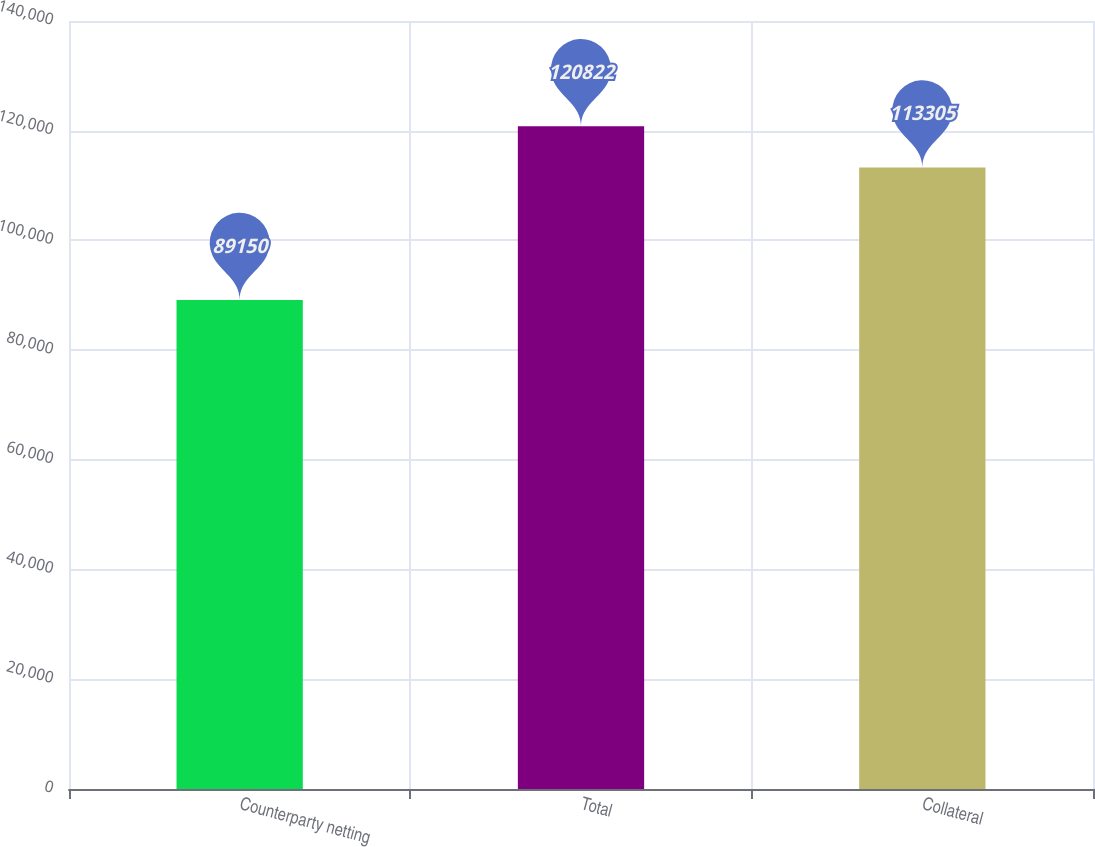Convert chart to OTSL. <chart><loc_0><loc_0><loc_500><loc_500><bar_chart><fcel>Counterparty netting<fcel>Total<fcel>Collateral<nl><fcel>89150<fcel>120822<fcel>113305<nl></chart> 